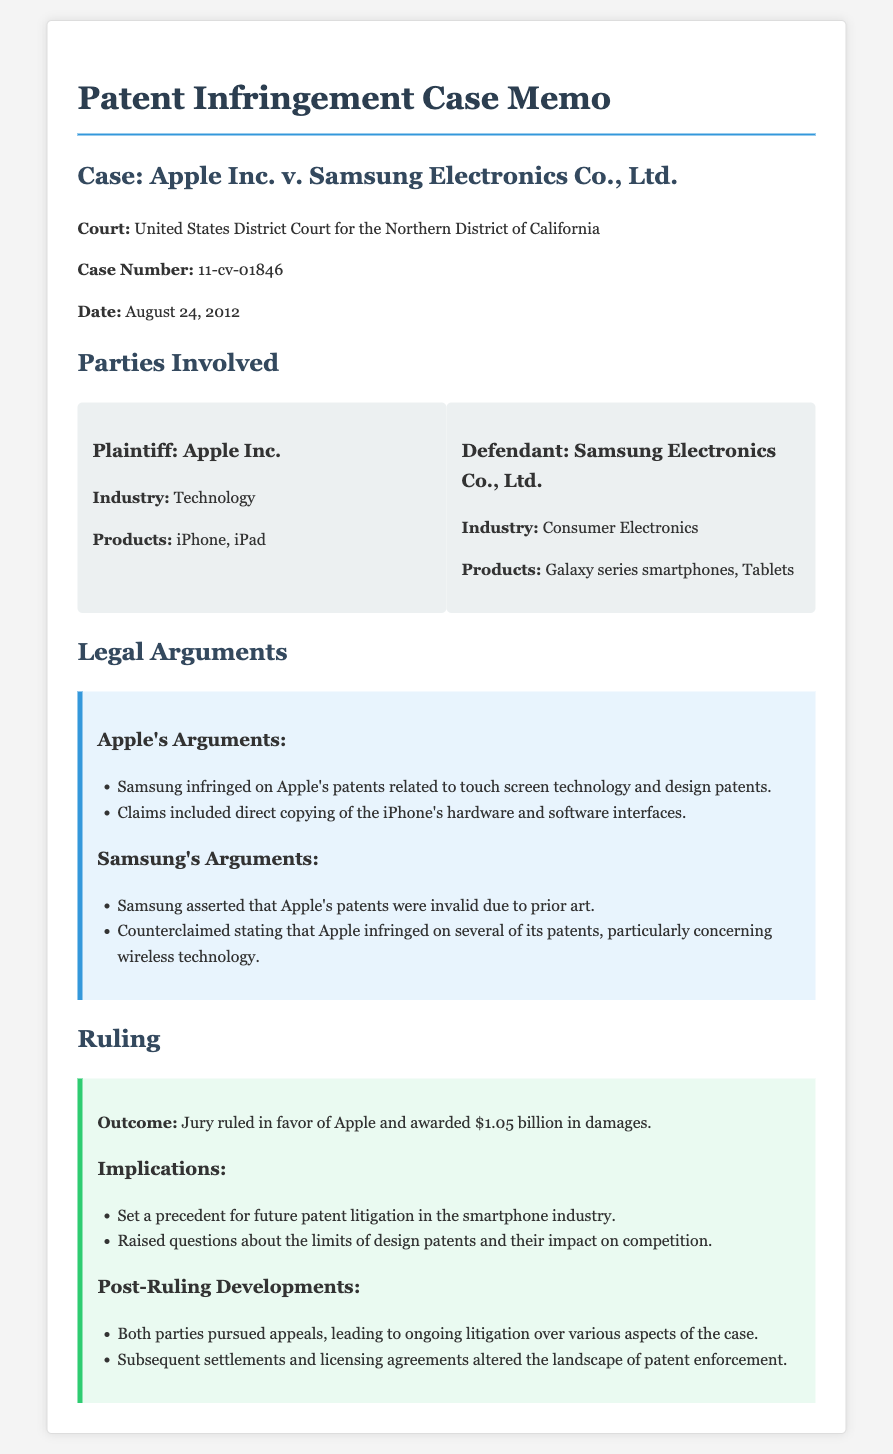What is the name of the plaintiff? The document states that the plaintiff in the case is Apple Inc.
Answer: Apple Inc Who is the defendant in this case? According to the document, the defendant involved in this case is Samsung Electronics Co., Ltd.
Answer: Samsung Electronics Co., Ltd What was the awarded damages amount? The document specifies that the jury ruled in favor of Apple and awarded them $1.05 billion in damages.
Answer: $1.05 billion Which court heard the case? The memo indicates that the case was heard in the United States District Court for the Northern District of California.
Answer: United States District Court for the Northern District of California What was one of Apple's main legal arguments? The document lists that one of Apple's arguments was that Samsung infringed on Apple's patents related to touchscreen technology and design patents.
Answer: Infringed on Apple's patents related to touchscreen technology and design patents What date was the ruling made? The document mentions that the ruling was made on August 24, 2012.
Answer: August 24, 2012 What precedent did the case set? The document outlines that the outcome set a precedent for future patent litigation in the smartphone industry.
Answer: Patent litigation in the smartphone industry What did Samsung argue about Apple's patents? The document states that Samsung asserted that Apple's patents were invalid due to prior art.
Answer: Invalid due to prior art 